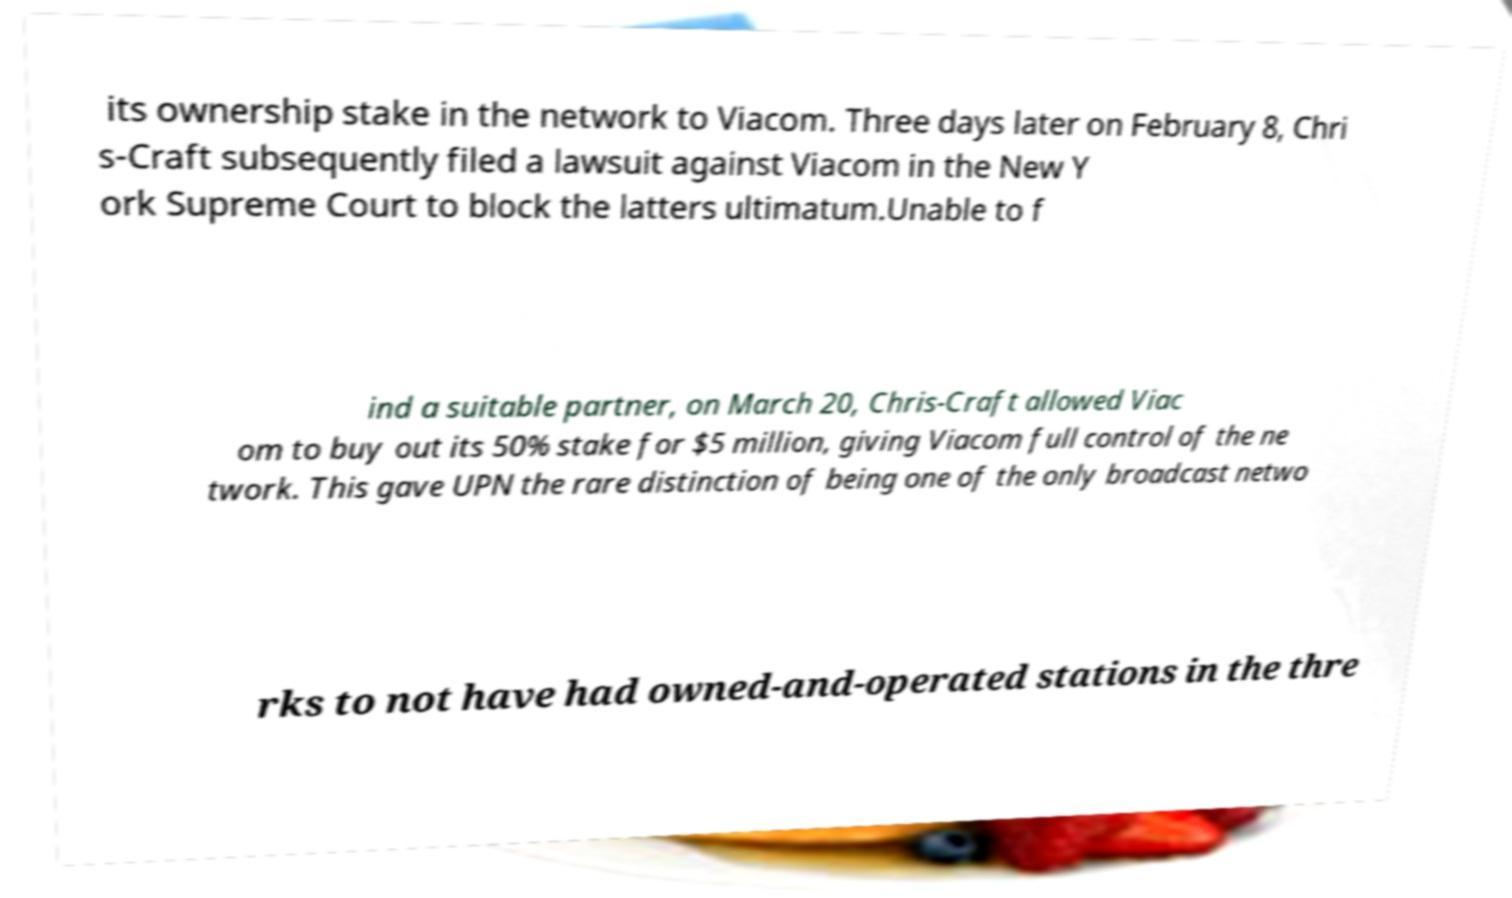Could you extract and type out the text from this image? its ownership stake in the network to Viacom. Three days later on February 8, Chri s-Craft subsequently filed a lawsuit against Viacom in the New Y ork Supreme Court to block the latters ultimatum.Unable to f ind a suitable partner, on March 20, Chris-Craft allowed Viac om to buy out its 50% stake for $5 million, giving Viacom full control of the ne twork. This gave UPN the rare distinction of being one of the only broadcast netwo rks to not have had owned-and-operated stations in the thre 